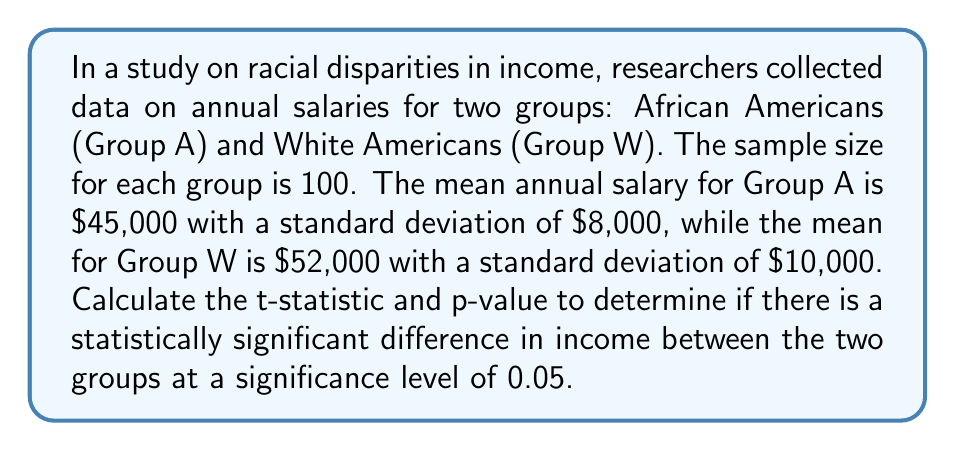Help me with this question. To determine if there is a statistically significant difference in income between the two groups, we need to perform an independent samples t-test. We'll follow these steps:

1. Calculate the pooled standard deviation:
   $$s_p = \sqrt{\frac{(n_A - 1)s_A^2 + (n_W - 1)s_W^2}{n_A + n_W - 2}}$$
   Where $n_A = n_W = 100$, $s_A = 8000$, and $s_W = 10000$

   $$s_p = \sqrt{\frac{(100 - 1)(8000)^2 + (100 - 1)(10000)^2}{100 + 100 - 2}}$$
   $$s_p = \sqrt{\frac{6.32 \times 10^9 + 9.9 \times 10^9}{198}} \approx 9055.39$$

2. Calculate the t-statistic:
   $$t = \frac{\bar{x}_W - \bar{x}_A}{s_p\sqrt{\frac{2}{n}}}$$
   Where $\bar{x}_W = 52000$, $\bar{x}_A = 45000$, and $n = 100$

   $$t = \frac{52000 - 45000}{9055.39\sqrt{\frac{2}{100}}} \approx 5.47$$

3. Calculate the degrees of freedom:
   $$df = n_A + n_W - 2 = 100 + 100 - 2 = 198$$

4. Determine the critical t-value for a two-tailed test at α = 0.05 with 198 degrees of freedom:
   $t_{crit} \approx \pm 1.97$

5. Calculate the p-value:
   Using a t-distribution calculator or table, we find that the p-value for t = 5.47 with 198 degrees of freedom is p < 0.0001.

6. Compare the t-statistic to the critical t-value and interpret the p-value:
   Since |5.47| > 1.97 and p < 0.0001 < 0.05, we reject the null hypothesis.
Answer: The t-statistic is approximately 5.47, and the p-value is less than 0.0001. Since the p-value is less than the significance level of 0.05, we conclude that there is a statistically significant difference in income between African Americans and White Americans in this study. 